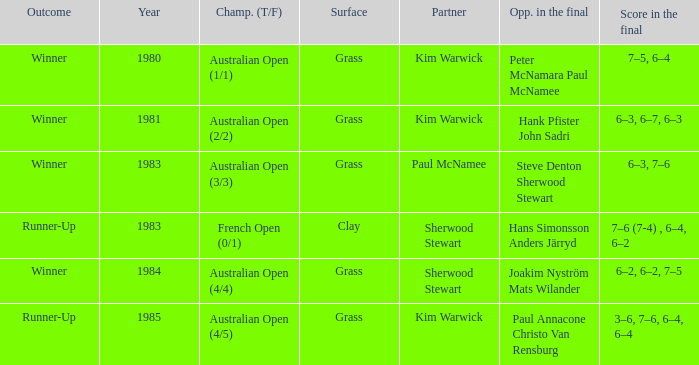What championship was played in 1981? Australian Open (2/2). 